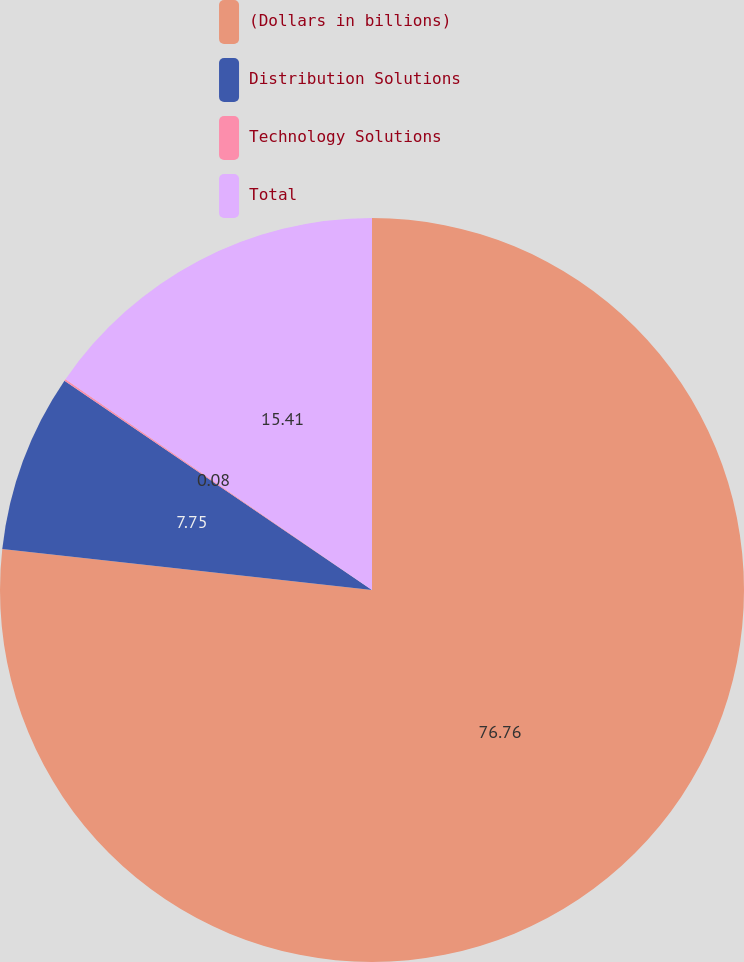Convert chart to OTSL. <chart><loc_0><loc_0><loc_500><loc_500><pie_chart><fcel>(Dollars in billions)<fcel>Distribution Solutions<fcel>Technology Solutions<fcel>Total<nl><fcel>76.76%<fcel>7.75%<fcel>0.08%<fcel>15.41%<nl></chart> 